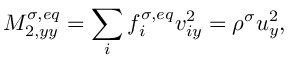<formula> <loc_0><loc_0><loc_500><loc_500>M _ { 2 , y y } ^ { \sigma , e q } = \sum _ { i } f _ { i } ^ { \sigma , e q } v _ { i y } ^ { 2 } = \rho ^ { \sigma } u _ { y } ^ { 2 } ,</formula> 